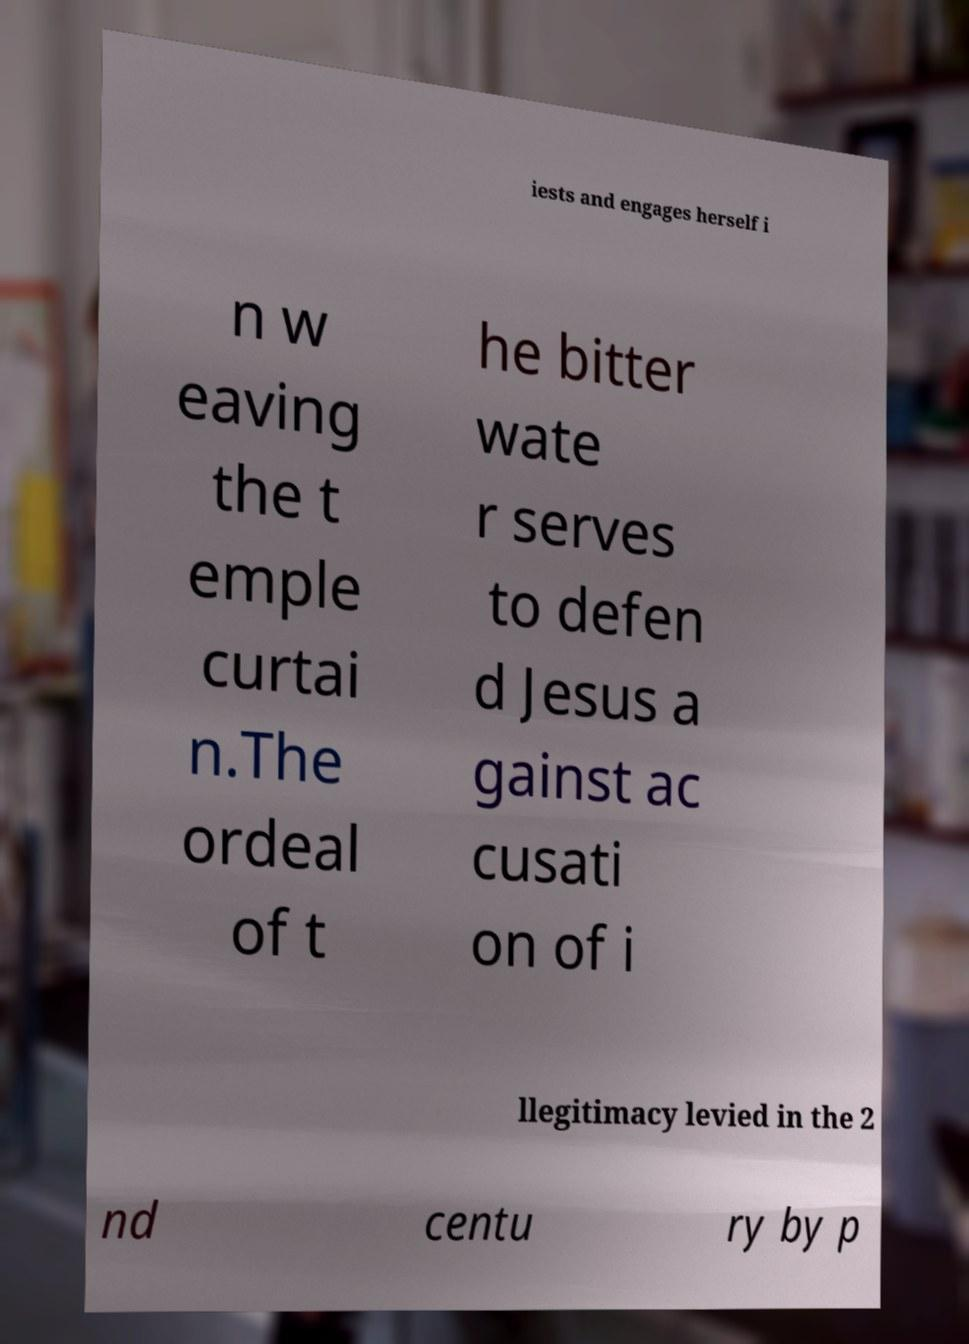For documentation purposes, I need the text within this image transcribed. Could you provide that? iests and engages herself i n w eaving the t emple curtai n.The ordeal of t he bitter wate r serves to defen d Jesus a gainst ac cusati on of i llegitimacy levied in the 2 nd centu ry by p 